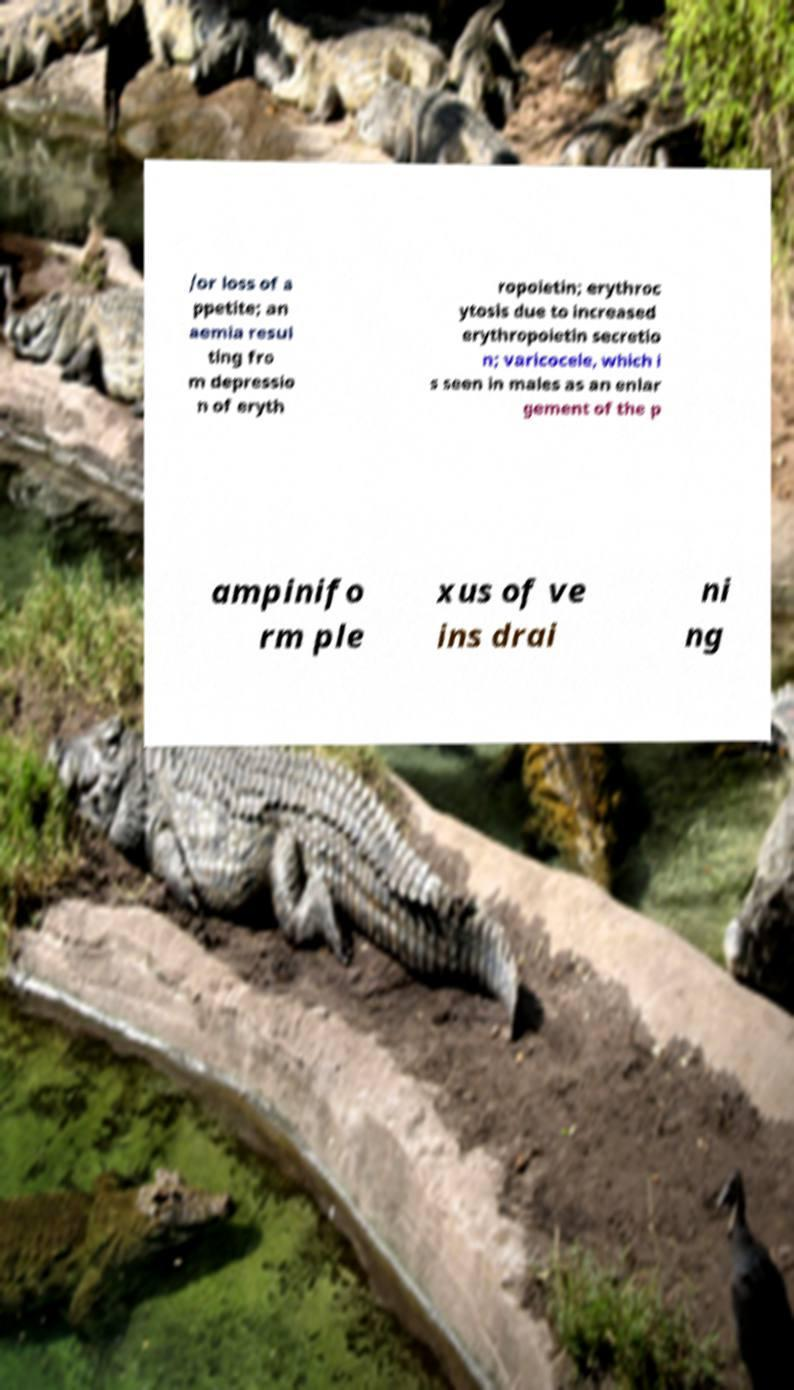I need the written content from this picture converted into text. Can you do that? /or loss of a ppetite; an aemia resul ting fro m depressio n of eryth ropoietin; erythroc ytosis due to increased erythropoietin secretio n; varicocele, which i s seen in males as an enlar gement of the p ampinifo rm ple xus of ve ins drai ni ng 